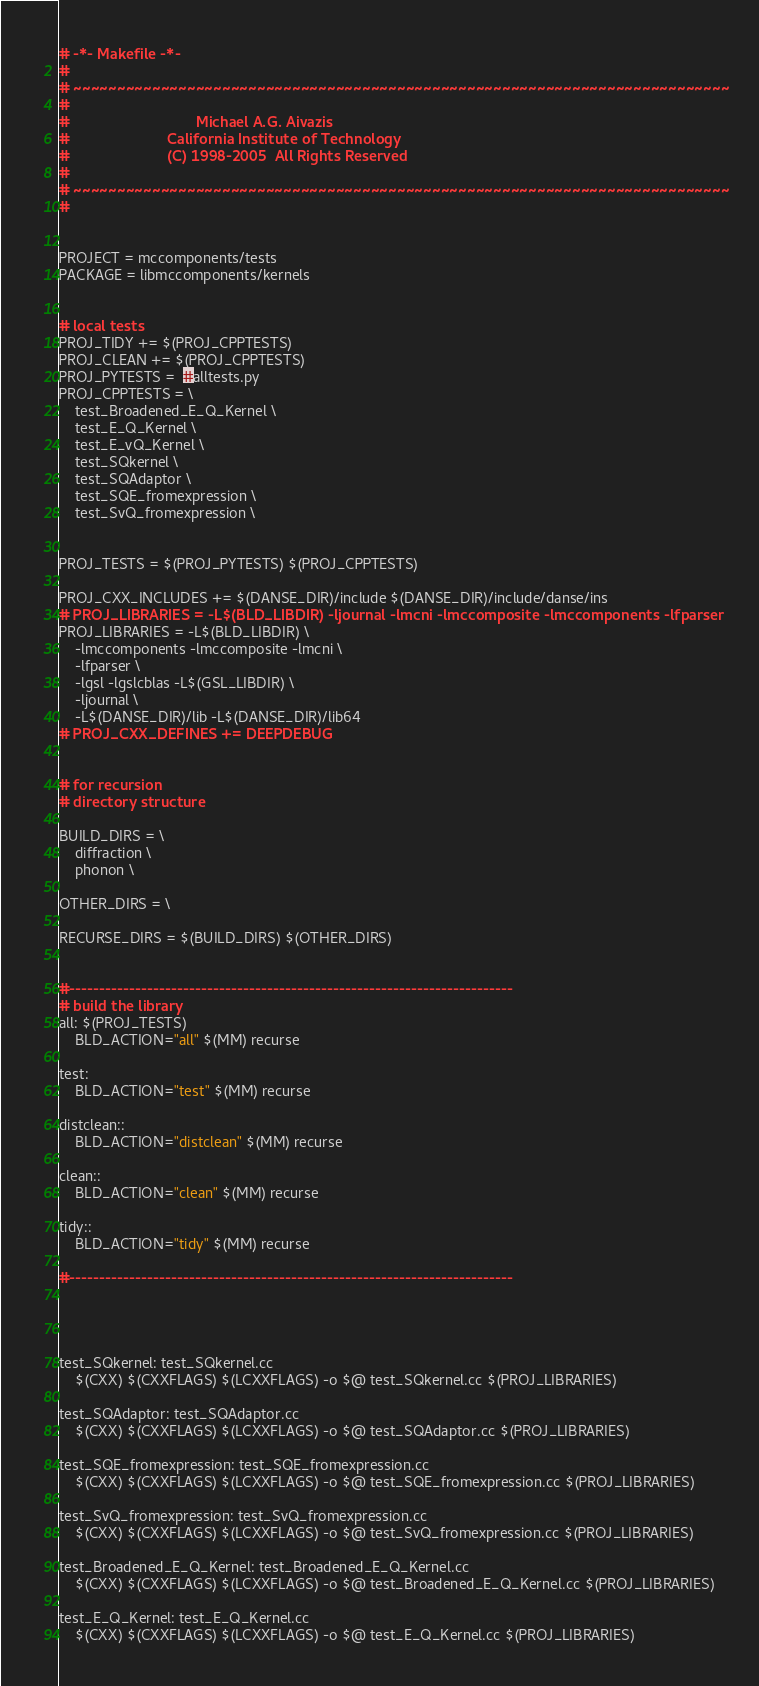<code> <loc_0><loc_0><loc_500><loc_500><_ObjectiveC_># -*- Makefile -*-
#
# ~~~~~~~~~~~~~~~~~~~~~~~~~~~~~~~~~~~~~~~~~~~~~~~~~~~~~~~~~~~~~~~~~~~~~~~~~~~
#
#                               Michael A.G. Aivazis
#                        California Institute of Technology
#                        (C) 1998-2005  All Rights Reserved
#
# ~~~~~~~~~~~~~~~~~~~~~~~~~~~~~~~~~~~~~~~~~~~~~~~~~~~~~~~~~~~~~~~~~~~~~~~~~~~
#


PROJECT = mccomponents/tests
PACKAGE = libmccomponents/kernels


# local tests
PROJ_TIDY += $(PROJ_CPPTESTS)
PROJ_CLEAN += $(PROJ_CPPTESTS)
PROJ_PYTESTS =  #alltests.py
PROJ_CPPTESTS = \
	test_Broadened_E_Q_Kernel \
	test_E_Q_Kernel \
	test_E_vQ_Kernel \
	test_SQkernel \
	test_SQAdaptor \
	test_SQE_fromexpression \
	test_SvQ_fromexpression \


PROJ_TESTS = $(PROJ_PYTESTS) $(PROJ_CPPTESTS)

PROJ_CXX_INCLUDES += $(DANSE_DIR)/include $(DANSE_DIR)/include/danse/ins
# PROJ_LIBRARIES = -L$(BLD_LIBDIR) -ljournal -lmcni -lmccomposite -lmccomponents -lfparser
PROJ_LIBRARIES = -L$(BLD_LIBDIR) \
	-lmccomponents -lmccomposite -lmcni \
	-lfparser \
	-lgsl -lgslcblas -L$(GSL_LIBDIR) \
	-ljournal \
	-L$(DANSE_DIR)/lib -L$(DANSE_DIR)/lib64
# PROJ_CXX_DEFINES += DEEPDEBUG


# for recursion
# directory structure

BUILD_DIRS = \
	diffraction \
	phonon \

OTHER_DIRS = \

RECURSE_DIRS = $(BUILD_DIRS) $(OTHER_DIRS)


#--------------------------------------------------------------------------
# build the library
all: $(PROJ_TESTS)
	BLD_ACTION="all" $(MM) recurse

test: 
	BLD_ACTION="test" $(MM) recurse

distclean::
	BLD_ACTION="distclean" $(MM) recurse

clean::
	BLD_ACTION="clean" $(MM) recurse

tidy::
	BLD_ACTION="tidy" $(MM) recurse

#--------------------------------------------------------------------------




test_SQkernel: test_SQkernel.cc
	$(CXX) $(CXXFLAGS) $(LCXXFLAGS) -o $@ test_SQkernel.cc $(PROJ_LIBRARIES)

test_SQAdaptor: test_SQAdaptor.cc
	$(CXX) $(CXXFLAGS) $(LCXXFLAGS) -o $@ test_SQAdaptor.cc $(PROJ_LIBRARIES)

test_SQE_fromexpression: test_SQE_fromexpression.cc
	$(CXX) $(CXXFLAGS) $(LCXXFLAGS) -o $@ test_SQE_fromexpression.cc $(PROJ_LIBRARIES)

test_SvQ_fromexpression: test_SvQ_fromexpression.cc
	$(CXX) $(CXXFLAGS) $(LCXXFLAGS) -o $@ test_SvQ_fromexpression.cc $(PROJ_LIBRARIES)

test_Broadened_E_Q_Kernel: test_Broadened_E_Q_Kernel.cc
	$(CXX) $(CXXFLAGS) $(LCXXFLAGS) -o $@ test_Broadened_E_Q_Kernel.cc $(PROJ_LIBRARIES)

test_E_Q_Kernel: test_E_Q_Kernel.cc
	$(CXX) $(CXXFLAGS) $(LCXXFLAGS) -o $@ test_E_Q_Kernel.cc $(PROJ_LIBRARIES)
</code> 